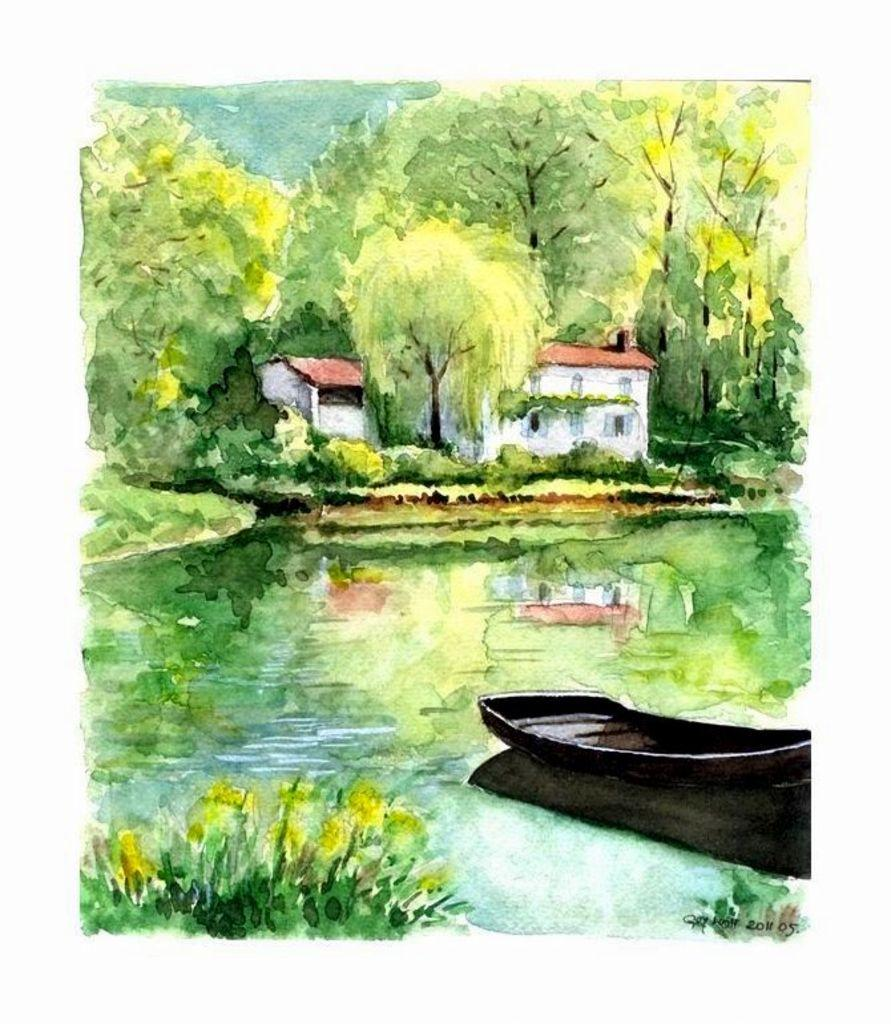What type of image is this, and what is its main feature? The image is edited and animated, and its main feature is a boat in the center. Where is the boat located in the image? The boat is on the water in the image. What can be seen in the background of the image? There is a building and trees in the background of the image. How many balls are bouncing around the boat in the image? There are no balls present in the image; it features a boat on the water with a background of a building and trees. 